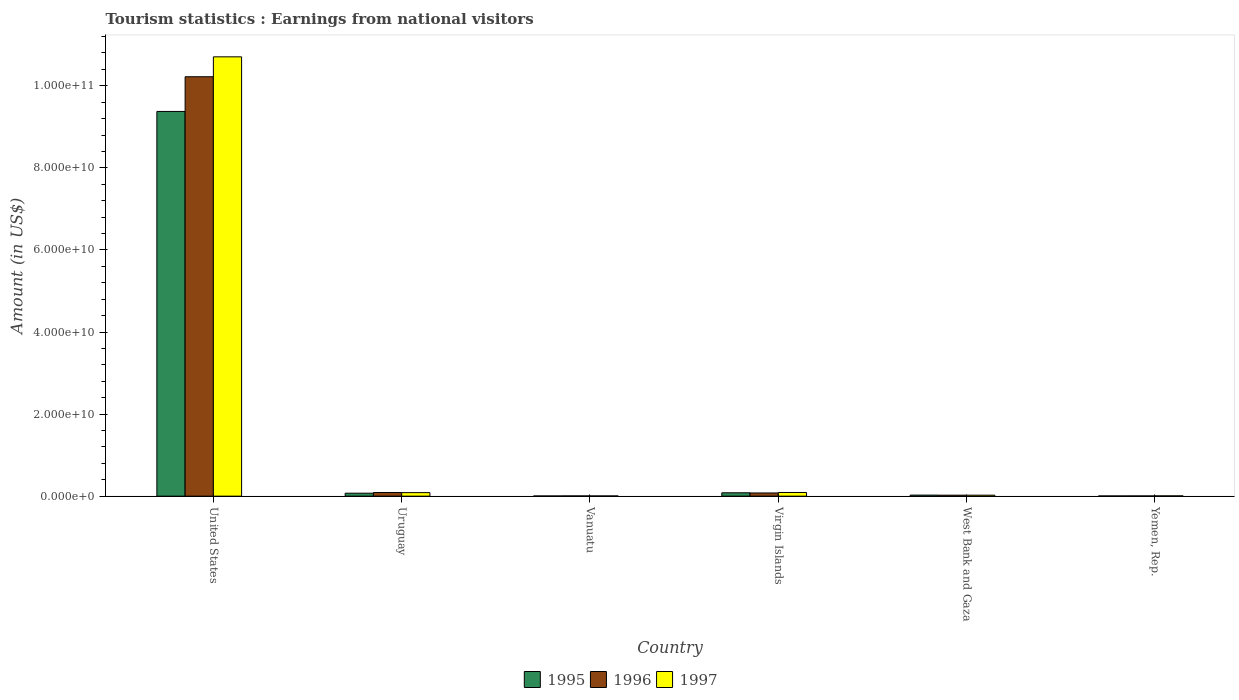How many different coloured bars are there?
Keep it short and to the point. 3. Are the number of bars on each tick of the X-axis equal?
Give a very brief answer. Yes. How many bars are there on the 6th tick from the left?
Give a very brief answer. 3. How many bars are there on the 1st tick from the right?
Your answer should be very brief. 3. What is the label of the 5th group of bars from the left?
Your response must be concise. West Bank and Gaza. In how many cases, is the number of bars for a given country not equal to the number of legend labels?
Give a very brief answer. 0. What is the earnings from national visitors in 1996 in Yemen, Rep.?
Make the answer very short. 5.50e+07. Across all countries, what is the maximum earnings from national visitors in 1996?
Ensure brevity in your answer.  1.02e+11. Across all countries, what is the minimum earnings from national visitors in 1995?
Offer a very short reply. 4.50e+07. In which country was the earnings from national visitors in 1996 maximum?
Make the answer very short. United States. In which country was the earnings from national visitors in 1995 minimum?
Your answer should be compact. Vanuatu. What is the total earnings from national visitors in 1996 in the graph?
Offer a very short reply. 1.04e+11. What is the difference between the earnings from national visitors in 1996 in Virgin Islands and that in Yemen, Rep.?
Your response must be concise. 7.26e+08. What is the difference between the earnings from national visitors in 1995 in Uruguay and the earnings from national visitors in 1996 in United States?
Offer a terse response. -1.01e+11. What is the average earnings from national visitors in 1996 per country?
Provide a succinct answer. 1.74e+1. In how many countries, is the earnings from national visitors in 1997 greater than 88000000000 US$?
Your answer should be compact. 1. What is the ratio of the earnings from national visitors in 1996 in United States to that in Yemen, Rep.?
Offer a very short reply. 1858.11. Is the earnings from national visitors in 1995 in Uruguay less than that in Yemen, Rep.?
Keep it short and to the point. No. Is the difference between the earnings from national visitors in 1997 in Virgin Islands and West Bank and Gaza greater than the difference between the earnings from national visitors in 1996 in Virgin Islands and West Bank and Gaza?
Your response must be concise. Yes. What is the difference between the highest and the second highest earnings from national visitors in 1996?
Offer a very short reply. 1.01e+11. What is the difference between the highest and the lowest earnings from national visitors in 1995?
Ensure brevity in your answer.  9.37e+1. In how many countries, is the earnings from national visitors in 1995 greater than the average earnings from national visitors in 1995 taken over all countries?
Offer a very short reply. 1. What does the 1st bar from the right in Virgin Islands represents?
Make the answer very short. 1997. What is the difference between two consecutive major ticks on the Y-axis?
Give a very brief answer. 2.00e+1. Are the values on the major ticks of Y-axis written in scientific E-notation?
Your answer should be very brief. Yes. Where does the legend appear in the graph?
Your answer should be compact. Bottom center. How many legend labels are there?
Your answer should be compact. 3. How are the legend labels stacked?
Provide a short and direct response. Horizontal. What is the title of the graph?
Ensure brevity in your answer.  Tourism statistics : Earnings from national visitors. What is the label or title of the X-axis?
Keep it short and to the point. Country. What is the Amount (in US$) of 1995 in United States?
Ensure brevity in your answer.  9.37e+1. What is the Amount (in US$) in 1996 in United States?
Ensure brevity in your answer.  1.02e+11. What is the Amount (in US$) in 1997 in United States?
Keep it short and to the point. 1.07e+11. What is the Amount (in US$) of 1995 in Uruguay?
Offer a very short reply. 7.25e+08. What is the Amount (in US$) of 1996 in Uruguay?
Offer a terse response. 8.90e+08. What is the Amount (in US$) of 1997 in Uruguay?
Ensure brevity in your answer.  8.62e+08. What is the Amount (in US$) of 1995 in Vanuatu?
Your response must be concise. 4.50e+07. What is the Amount (in US$) of 1996 in Vanuatu?
Provide a short and direct response. 5.60e+07. What is the Amount (in US$) of 1997 in Vanuatu?
Your answer should be very brief. 5.30e+07. What is the Amount (in US$) of 1995 in Virgin Islands?
Keep it short and to the point. 8.22e+08. What is the Amount (in US$) in 1996 in Virgin Islands?
Make the answer very short. 7.81e+08. What is the Amount (in US$) of 1997 in Virgin Islands?
Give a very brief answer. 8.94e+08. What is the Amount (in US$) of 1995 in West Bank and Gaza?
Provide a succinct answer. 2.55e+08. What is the Amount (in US$) of 1996 in West Bank and Gaza?
Ensure brevity in your answer.  2.42e+08. What is the Amount (in US$) in 1997 in West Bank and Gaza?
Make the answer very short. 2.39e+08. What is the Amount (in US$) of 1995 in Yemen, Rep.?
Ensure brevity in your answer.  5.00e+07. What is the Amount (in US$) of 1996 in Yemen, Rep.?
Ensure brevity in your answer.  5.50e+07. What is the Amount (in US$) of 1997 in Yemen, Rep.?
Provide a succinct answer. 7.00e+07. Across all countries, what is the maximum Amount (in US$) of 1995?
Ensure brevity in your answer.  9.37e+1. Across all countries, what is the maximum Amount (in US$) of 1996?
Your answer should be very brief. 1.02e+11. Across all countries, what is the maximum Amount (in US$) of 1997?
Offer a very short reply. 1.07e+11. Across all countries, what is the minimum Amount (in US$) of 1995?
Your response must be concise. 4.50e+07. Across all countries, what is the minimum Amount (in US$) in 1996?
Give a very brief answer. 5.50e+07. Across all countries, what is the minimum Amount (in US$) in 1997?
Make the answer very short. 5.30e+07. What is the total Amount (in US$) in 1995 in the graph?
Keep it short and to the point. 9.56e+1. What is the total Amount (in US$) in 1996 in the graph?
Provide a succinct answer. 1.04e+11. What is the total Amount (in US$) of 1997 in the graph?
Your answer should be compact. 1.09e+11. What is the difference between the Amount (in US$) of 1995 in United States and that in Uruguay?
Offer a very short reply. 9.30e+1. What is the difference between the Amount (in US$) of 1996 in United States and that in Uruguay?
Offer a very short reply. 1.01e+11. What is the difference between the Amount (in US$) in 1997 in United States and that in Uruguay?
Offer a terse response. 1.06e+11. What is the difference between the Amount (in US$) of 1995 in United States and that in Vanuatu?
Provide a succinct answer. 9.37e+1. What is the difference between the Amount (in US$) of 1996 in United States and that in Vanuatu?
Ensure brevity in your answer.  1.02e+11. What is the difference between the Amount (in US$) of 1997 in United States and that in Vanuatu?
Keep it short and to the point. 1.07e+11. What is the difference between the Amount (in US$) in 1995 in United States and that in Virgin Islands?
Provide a succinct answer. 9.29e+1. What is the difference between the Amount (in US$) in 1996 in United States and that in Virgin Islands?
Your answer should be very brief. 1.01e+11. What is the difference between the Amount (in US$) in 1997 in United States and that in Virgin Islands?
Your response must be concise. 1.06e+11. What is the difference between the Amount (in US$) in 1995 in United States and that in West Bank and Gaza?
Give a very brief answer. 9.35e+1. What is the difference between the Amount (in US$) of 1996 in United States and that in West Bank and Gaza?
Your response must be concise. 1.02e+11. What is the difference between the Amount (in US$) of 1997 in United States and that in West Bank and Gaza?
Offer a very short reply. 1.07e+11. What is the difference between the Amount (in US$) of 1995 in United States and that in Yemen, Rep.?
Your answer should be compact. 9.37e+1. What is the difference between the Amount (in US$) of 1996 in United States and that in Yemen, Rep.?
Your answer should be very brief. 1.02e+11. What is the difference between the Amount (in US$) of 1997 in United States and that in Yemen, Rep.?
Provide a succinct answer. 1.07e+11. What is the difference between the Amount (in US$) of 1995 in Uruguay and that in Vanuatu?
Make the answer very short. 6.80e+08. What is the difference between the Amount (in US$) of 1996 in Uruguay and that in Vanuatu?
Make the answer very short. 8.34e+08. What is the difference between the Amount (in US$) in 1997 in Uruguay and that in Vanuatu?
Give a very brief answer. 8.09e+08. What is the difference between the Amount (in US$) of 1995 in Uruguay and that in Virgin Islands?
Provide a succinct answer. -9.70e+07. What is the difference between the Amount (in US$) in 1996 in Uruguay and that in Virgin Islands?
Your answer should be compact. 1.09e+08. What is the difference between the Amount (in US$) of 1997 in Uruguay and that in Virgin Islands?
Your answer should be compact. -3.20e+07. What is the difference between the Amount (in US$) in 1995 in Uruguay and that in West Bank and Gaza?
Keep it short and to the point. 4.70e+08. What is the difference between the Amount (in US$) in 1996 in Uruguay and that in West Bank and Gaza?
Your answer should be compact. 6.48e+08. What is the difference between the Amount (in US$) in 1997 in Uruguay and that in West Bank and Gaza?
Your answer should be compact. 6.23e+08. What is the difference between the Amount (in US$) in 1995 in Uruguay and that in Yemen, Rep.?
Your response must be concise. 6.75e+08. What is the difference between the Amount (in US$) of 1996 in Uruguay and that in Yemen, Rep.?
Provide a short and direct response. 8.35e+08. What is the difference between the Amount (in US$) in 1997 in Uruguay and that in Yemen, Rep.?
Your answer should be very brief. 7.92e+08. What is the difference between the Amount (in US$) of 1995 in Vanuatu and that in Virgin Islands?
Your answer should be compact. -7.77e+08. What is the difference between the Amount (in US$) in 1996 in Vanuatu and that in Virgin Islands?
Give a very brief answer. -7.25e+08. What is the difference between the Amount (in US$) of 1997 in Vanuatu and that in Virgin Islands?
Offer a very short reply. -8.41e+08. What is the difference between the Amount (in US$) of 1995 in Vanuatu and that in West Bank and Gaza?
Offer a very short reply. -2.10e+08. What is the difference between the Amount (in US$) of 1996 in Vanuatu and that in West Bank and Gaza?
Your answer should be very brief. -1.86e+08. What is the difference between the Amount (in US$) in 1997 in Vanuatu and that in West Bank and Gaza?
Ensure brevity in your answer.  -1.86e+08. What is the difference between the Amount (in US$) of 1995 in Vanuatu and that in Yemen, Rep.?
Provide a succinct answer. -5.00e+06. What is the difference between the Amount (in US$) in 1996 in Vanuatu and that in Yemen, Rep.?
Your answer should be compact. 1.00e+06. What is the difference between the Amount (in US$) of 1997 in Vanuatu and that in Yemen, Rep.?
Keep it short and to the point. -1.70e+07. What is the difference between the Amount (in US$) of 1995 in Virgin Islands and that in West Bank and Gaza?
Offer a very short reply. 5.67e+08. What is the difference between the Amount (in US$) of 1996 in Virgin Islands and that in West Bank and Gaza?
Keep it short and to the point. 5.39e+08. What is the difference between the Amount (in US$) in 1997 in Virgin Islands and that in West Bank and Gaza?
Provide a short and direct response. 6.55e+08. What is the difference between the Amount (in US$) in 1995 in Virgin Islands and that in Yemen, Rep.?
Offer a very short reply. 7.72e+08. What is the difference between the Amount (in US$) of 1996 in Virgin Islands and that in Yemen, Rep.?
Provide a succinct answer. 7.26e+08. What is the difference between the Amount (in US$) of 1997 in Virgin Islands and that in Yemen, Rep.?
Provide a short and direct response. 8.24e+08. What is the difference between the Amount (in US$) of 1995 in West Bank and Gaza and that in Yemen, Rep.?
Make the answer very short. 2.05e+08. What is the difference between the Amount (in US$) of 1996 in West Bank and Gaza and that in Yemen, Rep.?
Your response must be concise. 1.87e+08. What is the difference between the Amount (in US$) of 1997 in West Bank and Gaza and that in Yemen, Rep.?
Make the answer very short. 1.69e+08. What is the difference between the Amount (in US$) in 1995 in United States and the Amount (in US$) in 1996 in Uruguay?
Offer a terse response. 9.29e+1. What is the difference between the Amount (in US$) of 1995 in United States and the Amount (in US$) of 1997 in Uruguay?
Give a very brief answer. 9.29e+1. What is the difference between the Amount (in US$) of 1996 in United States and the Amount (in US$) of 1997 in Uruguay?
Provide a short and direct response. 1.01e+11. What is the difference between the Amount (in US$) of 1995 in United States and the Amount (in US$) of 1996 in Vanuatu?
Give a very brief answer. 9.37e+1. What is the difference between the Amount (in US$) in 1995 in United States and the Amount (in US$) in 1997 in Vanuatu?
Your answer should be very brief. 9.37e+1. What is the difference between the Amount (in US$) of 1996 in United States and the Amount (in US$) of 1997 in Vanuatu?
Ensure brevity in your answer.  1.02e+11. What is the difference between the Amount (in US$) of 1995 in United States and the Amount (in US$) of 1996 in Virgin Islands?
Ensure brevity in your answer.  9.30e+1. What is the difference between the Amount (in US$) in 1995 in United States and the Amount (in US$) in 1997 in Virgin Islands?
Make the answer very short. 9.28e+1. What is the difference between the Amount (in US$) of 1996 in United States and the Amount (in US$) of 1997 in Virgin Islands?
Ensure brevity in your answer.  1.01e+11. What is the difference between the Amount (in US$) in 1995 in United States and the Amount (in US$) in 1996 in West Bank and Gaza?
Give a very brief answer. 9.35e+1. What is the difference between the Amount (in US$) of 1995 in United States and the Amount (in US$) of 1997 in West Bank and Gaza?
Your answer should be very brief. 9.35e+1. What is the difference between the Amount (in US$) of 1996 in United States and the Amount (in US$) of 1997 in West Bank and Gaza?
Your response must be concise. 1.02e+11. What is the difference between the Amount (in US$) of 1995 in United States and the Amount (in US$) of 1996 in Yemen, Rep.?
Your response must be concise. 9.37e+1. What is the difference between the Amount (in US$) of 1995 in United States and the Amount (in US$) of 1997 in Yemen, Rep.?
Provide a short and direct response. 9.37e+1. What is the difference between the Amount (in US$) of 1996 in United States and the Amount (in US$) of 1997 in Yemen, Rep.?
Offer a very short reply. 1.02e+11. What is the difference between the Amount (in US$) of 1995 in Uruguay and the Amount (in US$) of 1996 in Vanuatu?
Your answer should be compact. 6.69e+08. What is the difference between the Amount (in US$) in 1995 in Uruguay and the Amount (in US$) in 1997 in Vanuatu?
Your answer should be compact. 6.72e+08. What is the difference between the Amount (in US$) of 1996 in Uruguay and the Amount (in US$) of 1997 in Vanuatu?
Provide a succinct answer. 8.37e+08. What is the difference between the Amount (in US$) of 1995 in Uruguay and the Amount (in US$) of 1996 in Virgin Islands?
Your response must be concise. -5.60e+07. What is the difference between the Amount (in US$) in 1995 in Uruguay and the Amount (in US$) in 1997 in Virgin Islands?
Your answer should be very brief. -1.69e+08. What is the difference between the Amount (in US$) of 1996 in Uruguay and the Amount (in US$) of 1997 in Virgin Islands?
Make the answer very short. -4.00e+06. What is the difference between the Amount (in US$) of 1995 in Uruguay and the Amount (in US$) of 1996 in West Bank and Gaza?
Offer a very short reply. 4.83e+08. What is the difference between the Amount (in US$) in 1995 in Uruguay and the Amount (in US$) in 1997 in West Bank and Gaza?
Give a very brief answer. 4.86e+08. What is the difference between the Amount (in US$) in 1996 in Uruguay and the Amount (in US$) in 1997 in West Bank and Gaza?
Ensure brevity in your answer.  6.51e+08. What is the difference between the Amount (in US$) of 1995 in Uruguay and the Amount (in US$) of 1996 in Yemen, Rep.?
Ensure brevity in your answer.  6.70e+08. What is the difference between the Amount (in US$) of 1995 in Uruguay and the Amount (in US$) of 1997 in Yemen, Rep.?
Give a very brief answer. 6.55e+08. What is the difference between the Amount (in US$) of 1996 in Uruguay and the Amount (in US$) of 1997 in Yemen, Rep.?
Give a very brief answer. 8.20e+08. What is the difference between the Amount (in US$) in 1995 in Vanuatu and the Amount (in US$) in 1996 in Virgin Islands?
Your response must be concise. -7.36e+08. What is the difference between the Amount (in US$) of 1995 in Vanuatu and the Amount (in US$) of 1997 in Virgin Islands?
Offer a very short reply. -8.49e+08. What is the difference between the Amount (in US$) in 1996 in Vanuatu and the Amount (in US$) in 1997 in Virgin Islands?
Your response must be concise. -8.38e+08. What is the difference between the Amount (in US$) in 1995 in Vanuatu and the Amount (in US$) in 1996 in West Bank and Gaza?
Your response must be concise. -1.97e+08. What is the difference between the Amount (in US$) in 1995 in Vanuatu and the Amount (in US$) in 1997 in West Bank and Gaza?
Your response must be concise. -1.94e+08. What is the difference between the Amount (in US$) in 1996 in Vanuatu and the Amount (in US$) in 1997 in West Bank and Gaza?
Offer a very short reply. -1.83e+08. What is the difference between the Amount (in US$) of 1995 in Vanuatu and the Amount (in US$) of 1996 in Yemen, Rep.?
Your answer should be compact. -1.00e+07. What is the difference between the Amount (in US$) in 1995 in Vanuatu and the Amount (in US$) in 1997 in Yemen, Rep.?
Offer a terse response. -2.50e+07. What is the difference between the Amount (in US$) of 1996 in Vanuatu and the Amount (in US$) of 1997 in Yemen, Rep.?
Offer a very short reply. -1.40e+07. What is the difference between the Amount (in US$) of 1995 in Virgin Islands and the Amount (in US$) of 1996 in West Bank and Gaza?
Your response must be concise. 5.80e+08. What is the difference between the Amount (in US$) in 1995 in Virgin Islands and the Amount (in US$) in 1997 in West Bank and Gaza?
Give a very brief answer. 5.83e+08. What is the difference between the Amount (in US$) in 1996 in Virgin Islands and the Amount (in US$) in 1997 in West Bank and Gaza?
Give a very brief answer. 5.42e+08. What is the difference between the Amount (in US$) of 1995 in Virgin Islands and the Amount (in US$) of 1996 in Yemen, Rep.?
Ensure brevity in your answer.  7.67e+08. What is the difference between the Amount (in US$) in 1995 in Virgin Islands and the Amount (in US$) in 1997 in Yemen, Rep.?
Make the answer very short. 7.52e+08. What is the difference between the Amount (in US$) in 1996 in Virgin Islands and the Amount (in US$) in 1997 in Yemen, Rep.?
Make the answer very short. 7.11e+08. What is the difference between the Amount (in US$) in 1995 in West Bank and Gaza and the Amount (in US$) in 1997 in Yemen, Rep.?
Provide a succinct answer. 1.85e+08. What is the difference between the Amount (in US$) in 1996 in West Bank and Gaza and the Amount (in US$) in 1997 in Yemen, Rep.?
Provide a succinct answer. 1.72e+08. What is the average Amount (in US$) of 1995 per country?
Ensure brevity in your answer.  1.59e+1. What is the average Amount (in US$) in 1996 per country?
Make the answer very short. 1.74e+1. What is the average Amount (in US$) of 1997 per country?
Your answer should be compact. 1.82e+1. What is the difference between the Amount (in US$) of 1995 and Amount (in US$) of 1996 in United States?
Make the answer very short. -8.45e+09. What is the difference between the Amount (in US$) of 1995 and Amount (in US$) of 1997 in United States?
Make the answer very short. -1.33e+1. What is the difference between the Amount (in US$) of 1996 and Amount (in US$) of 1997 in United States?
Your answer should be very brief. -4.85e+09. What is the difference between the Amount (in US$) of 1995 and Amount (in US$) of 1996 in Uruguay?
Ensure brevity in your answer.  -1.65e+08. What is the difference between the Amount (in US$) of 1995 and Amount (in US$) of 1997 in Uruguay?
Your answer should be compact. -1.37e+08. What is the difference between the Amount (in US$) in 1996 and Amount (in US$) in 1997 in Uruguay?
Provide a succinct answer. 2.80e+07. What is the difference between the Amount (in US$) of 1995 and Amount (in US$) of 1996 in Vanuatu?
Provide a short and direct response. -1.10e+07. What is the difference between the Amount (in US$) of 1995 and Amount (in US$) of 1997 in Vanuatu?
Offer a very short reply. -8.00e+06. What is the difference between the Amount (in US$) of 1995 and Amount (in US$) of 1996 in Virgin Islands?
Offer a terse response. 4.10e+07. What is the difference between the Amount (in US$) in 1995 and Amount (in US$) in 1997 in Virgin Islands?
Provide a short and direct response. -7.20e+07. What is the difference between the Amount (in US$) in 1996 and Amount (in US$) in 1997 in Virgin Islands?
Keep it short and to the point. -1.13e+08. What is the difference between the Amount (in US$) of 1995 and Amount (in US$) of 1996 in West Bank and Gaza?
Provide a succinct answer. 1.30e+07. What is the difference between the Amount (in US$) in 1995 and Amount (in US$) in 1997 in West Bank and Gaza?
Make the answer very short. 1.60e+07. What is the difference between the Amount (in US$) of 1996 and Amount (in US$) of 1997 in West Bank and Gaza?
Keep it short and to the point. 3.00e+06. What is the difference between the Amount (in US$) in 1995 and Amount (in US$) in 1996 in Yemen, Rep.?
Your answer should be compact. -5.00e+06. What is the difference between the Amount (in US$) of 1995 and Amount (in US$) of 1997 in Yemen, Rep.?
Your answer should be compact. -2.00e+07. What is the difference between the Amount (in US$) in 1996 and Amount (in US$) in 1997 in Yemen, Rep.?
Offer a terse response. -1.50e+07. What is the ratio of the Amount (in US$) in 1995 in United States to that in Uruguay?
Give a very brief answer. 129.3. What is the ratio of the Amount (in US$) of 1996 in United States to that in Uruguay?
Provide a short and direct response. 114.83. What is the ratio of the Amount (in US$) in 1997 in United States to that in Uruguay?
Your response must be concise. 124.18. What is the ratio of the Amount (in US$) of 1995 in United States to that in Vanuatu?
Give a very brief answer. 2083.18. What is the ratio of the Amount (in US$) in 1996 in United States to that in Vanuatu?
Make the answer very short. 1824.93. What is the ratio of the Amount (in US$) in 1997 in United States to that in Vanuatu?
Your answer should be compact. 2019.75. What is the ratio of the Amount (in US$) of 1995 in United States to that in Virgin Islands?
Offer a terse response. 114.04. What is the ratio of the Amount (in US$) in 1996 in United States to that in Virgin Islands?
Your answer should be very brief. 130.85. What is the ratio of the Amount (in US$) in 1997 in United States to that in Virgin Islands?
Your answer should be compact. 119.74. What is the ratio of the Amount (in US$) in 1995 in United States to that in West Bank and Gaza?
Your answer should be very brief. 367.62. What is the ratio of the Amount (in US$) in 1996 in United States to that in West Bank and Gaza?
Offer a very short reply. 422.3. What is the ratio of the Amount (in US$) of 1997 in United States to that in West Bank and Gaza?
Give a very brief answer. 447.9. What is the ratio of the Amount (in US$) in 1995 in United States to that in Yemen, Rep.?
Give a very brief answer. 1874.86. What is the ratio of the Amount (in US$) in 1996 in United States to that in Yemen, Rep.?
Keep it short and to the point. 1858.11. What is the ratio of the Amount (in US$) in 1997 in United States to that in Yemen, Rep.?
Your answer should be compact. 1529.24. What is the ratio of the Amount (in US$) in 1995 in Uruguay to that in Vanuatu?
Make the answer very short. 16.11. What is the ratio of the Amount (in US$) of 1996 in Uruguay to that in Vanuatu?
Provide a short and direct response. 15.89. What is the ratio of the Amount (in US$) of 1997 in Uruguay to that in Vanuatu?
Your answer should be compact. 16.26. What is the ratio of the Amount (in US$) in 1995 in Uruguay to that in Virgin Islands?
Your answer should be compact. 0.88. What is the ratio of the Amount (in US$) in 1996 in Uruguay to that in Virgin Islands?
Your answer should be compact. 1.14. What is the ratio of the Amount (in US$) in 1997 in Uruguay to that in Virgin Islands?
Your response must be concise. 0.96. What is the ratio of the Amount (in US$) of 1995 in Uruguay to that in West Bank and Gaza?
Give a very brief answer. 2.84. What is the ratio of the Amount (in US$) of 1996 in Uruguay to that in West Bank and Gaza?
Provide a succinct answer. 3.68. What is the ratio of the Amount (in US$) in 1997 in Uruguay to that in West Bank and Gaza?
Provide a succinct answer. 3.61. What is the ratio of the Amount (in US$) of 1995 in Uruguay to that in Yemen, Rep.?
Offer a terse response. 14.5. What is the ratio of the Amount (in US$) in 1996 in Uruguay to that in Yemen, Rep.?
Offer a terse response. 16.18. What is the ratio of the Amount (in US$) in 1997 in Uruguay to that in Yemen, Rep.?
Give a very brief answer. 12.31. What is the ratio of the Amount (in US$) in 1995 in Vanuatu to that in Virgin Islands?
Provide a short and direct response. 0.05. What is the ratio of the Amount (in US$) in 1996 in Vanuatu to that in Virgin Islands?
Provide a succinct answer. 0.07. What is the ratio of the Amount (in US$) in 1997 in Vanuatu to that in Virgin Islands?
Keep it short and to the point. 0.06. What is the ratio of the Amount (in US$) in 1995 in Vanuatu to that in West Bank and Gaza?
Give a very brief answer. 0.18. What is the ratio of the Amount (in US$) in 1996 in Vanuatu to that in West Bank and Gaza?
Provide a succinct answer. 0.23. What is the ratio of the Amount (in US$) of 1997 in Vanuatu to that in West Bank and Gaza?
Provide a succinct answer. 0.22. What is the ratio of the Amount (in US$) of 1996 in Vanuatu to that in Yemen, Rep.?
Your answer should be very brief. 1.02. What is the ratio of the Amount (in US$) in 1997 in Vanuatu to that in Yemen, Rep.?
Offer a very short reply. 0.76. What is the ratio of the Amount (in US$) of 1995 in Virgin Islands to that in West Bank and Gaza?
Give a very brief answer. 3.22. What is the ratio of the Amount (in US$) in 1996 in Virgin Islands to that in West Bank and Gaza?
Your answer should be very brief. 3.23. What is the ratio of the Amount (in US$) of 1997 in Virgin Islands to that in West Bank and Gaza?
Offer a very short reply. 3.74. What is the ratio of the Amount (in US$) of 1995 in Virgin Islands to that in Yemen, Rep.?
Offer a very short reply. 16.44. What is the ratio of the Amount (in US$) of 1997 in Virgin Islands to that in Yemen, Rep.?
Provide a succinct answer. 12.77. What is the ratio of the Amount (in US$) of 1996 in West Bank and Gaza to that in Yemen, Rep.?
Make the answer very short. 4.4. What is the ratio of the Amount (in US$) in 1997 in West Bank and Gaza to that in Yemen, Rep.?
Offer a very short reply. 3.41. What is the difference between the highest and the second highest Amount (in US$) of 1995?
Make the answer very short. 9.29e+1. What is the difference between the highest and the second highest Amount (in US$) in 1996?
Give a very brief answer. 1.01e+11. What is the difference between the highest and the second highest Amount (in US$) of 1997?
Offer a terse response. 1.06e+11. What is the difference between the highest and the lowest Amount (in US$) of 1995?
Keep it short and to the point. 9.37e+1. What is the difference between the highest and the lowest Amount (in US$) of 1996?
Give a very brief answer. 1.02e+11. What is the difference between the highest and the lowest Amount (in US$) in 1997?
Your answer should be compact. 1.07e+11. 